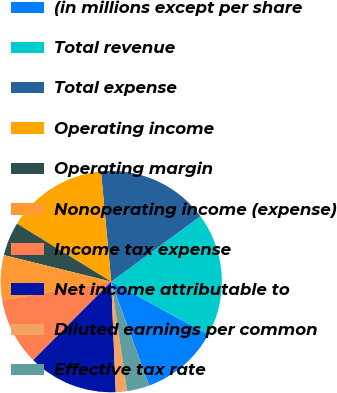Convert chart to OTSL. <chart><loc_0><loc_0><loc_500><loc_500><pie_chart><fcel>(in millions except per share<fcel>Total revenue<fcel>Total expense<fcel>Operating income<fcel>Operating margin<fcel>Nonoperating income (expense)<fcel>Income tax expense<fcel>Net income attributable to<fcel>Diluted earnings per common<fcel>Effective tax rate<nl><fcel>11.48%<fcel>18.03%<fcel>16.39%<fcel>14.75%<fcel>4.92%<fcel>6.56%<fcel>9.84%<fcel>13.11%<fcel>1.64%<fcel>3.28%<nl></chart> 